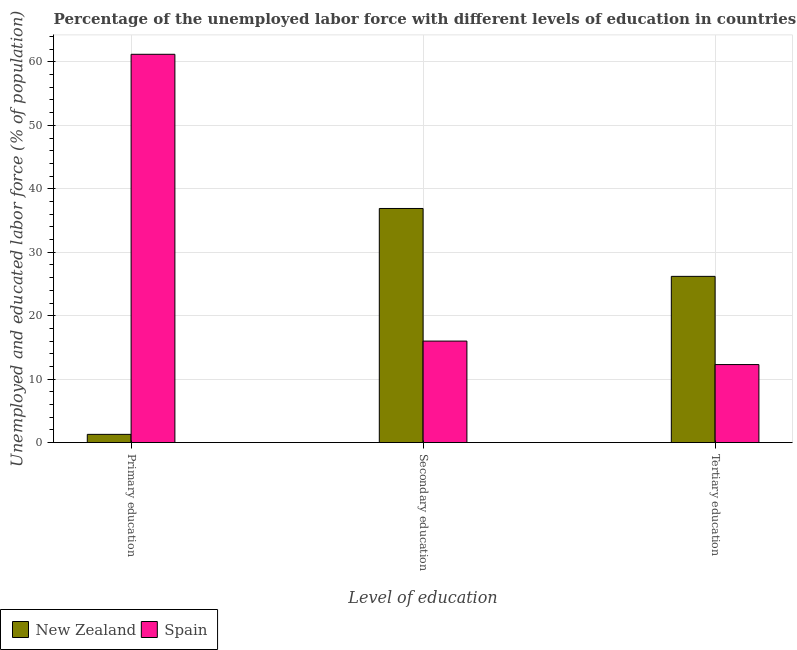How many groups of bars are there?
Your response must be concise. 3. Are the number of bars on each tick of the X-axis equal?
Offer a very short reply. Yes. How many bars are there on the 3rd tick from the left?
Your answer should be very brief. 2. How many bars are there on the 3rd tick from the right?
Offer a very short reply. 2. What is the label of the 2nd group of bars from the left?
Give a very brief answer. Secondary education. What is the percentage of labor force who received primary education in New Zealand?
Your response must be concise. 1.3. Across all countries, what is the maximum percentage of labor force who received tertiary education?
Provide a succinct answer. 26.2. Across all countries, what is the minimum percentage of labor force who received tertiary education?
Your answer should be very brief. 12.3. In which country was the percentage of labor force who received secondary education maximum?
Your response must be concise. New Zealand. In which country was the percentage of labor force who received primary education minimum?
Provide a succinct answer. New Zealand. What is the total percentage of labor force who received secondary education in the graph?
Keep it short and to the point. 52.9. What is the difference between the percentage of labor force who received tertiary education in Spain and that in New Zealand?
Your answer should be very brief. -13.9. What is the difference between the percentage of labor force who received secondary education in New Zealand and the percentage of labor force who received primary education in Spain?
Make the answer very short. -24.3. What is the average percentage of labor force who received secondary education per country?
Your response must be concise. 26.45. What is the difference between the percentage of labor force who received secondary education and percentage of labor force who received primary education in New Zealand?
Your answer should be compact. 35.6. What is the ratio of the percentage of labor force who received tertiary education in New Zealand to that in Spain?
Make the answer very short. 2.13. Is the percentage of labor force who received primary education in Spain less than that in New Zealand?
Provide a short and direct response. No. What is the difference between the highest and the second highest percentage of labor force who received tertiary education?
Your response must be concise. 13.9. What is the difference between the highest and the lowest percentage of labor force who received tertiary education?
Provide a short and direct response. 13.9. In how many countries, is the percentage of labor force who received primary education greater than the average percentage of labor force who received primary education taken over all countries?
Provide a succinct answer. 1. What does the 1st bar from the left in Tertiary education represents?
Make the answer very short. New Zealand. What does the 2nd bar from the right in Secondary education represents?
Your answer should be very brief. New Zealand. Does the graph contain any zero values?
Offer a terse response. No. Does the graph contain grids?
Your response must be concise. Yes. Where does the legend appear in the graph?
Provide a short and direct response. Bottom left. How many legend labels are there?
Offer a very short reply. 2. What is the title of the graph?
Your answer should be very brief. Percentage of the unemployed labor force with different levels of education in countries. Does "Faeroe Islands" appear as one of the legend labels in the graph?
Provide a succinct answer. No. What is the label or title of the X-axis?
Give a very brief answer. Level of education. What is the label or title of the Y-axis?
Provide a short and direct response. Unemployed and educated labor force (% of population). What is the Unemployed and educated labor force (% of population) in New Zealand in Primary education?
Offer a very short reply. 1.3. What is the Unemployed and educated labor force (% of population) in Spain in Primary education?
Your answer should be compact. 61.2. What is the Unemployed and educated labor force (% of population) in New Zealand in Secondary education?
Give a very brief answer. 36.9. What is the Unemployed and educated labor force (% of population) of Spain in Secondary education?
Offer a very short reply. 16. What is the Unemployed and educated labor force (% of population) of New Zealand in Tertiary education?
Your answer should be very brief. 26.2. What is the Unemployed and educated labor force (% of population) in Spain in Tertiary education?
Your answer should be compact. 12.3. Across all Level of education, what is the maximum Unemployed and educated labor force (% of population) of New Zealand?
Offer a terse response. 36.9. Across all Level of education, what is the maximum Unemployed and educated labor force (% of population) of Spain?
Offer a very short reply. 61.2. Across all Level of education, what is the minimum Unemployed and educated labor force (% of population) of New Zealand?
Your answer should be very brief. 1.3. Across all Level of education, what is the minimum Unemployed and educated labor force (% of population) in Spain?
Your response must be concise. 12.3. What is the total Unemployed and educated labor force (% of population) in New Zealand in the graph?
Keep it short and to the point. 64.4. What is the total Unemployed and educated labor force (% of population) in Spain in the graph?
Give a very brief answer. 89.5. What is the difference between the Unemployed and educated labor force (% of population) of New Zealand in Primary education and that in Secondary education?
Offer a terse response. -35.6. What is the difference between the Unemployed and educated labor force (% of population) of Spain in Primary education and that in Secondary education?
Provide a short and direct response. 45.2. What is the difference between the Unemployed and educated labor force (% of population) in New Zealand in Primary education and that in Tertiary education?
Provide a succinct answer. -24.9. What is the difference between the Unemployed and educated labor force (% of population) in Spain in Primary education and that in Tertiary education?
Provide a succinct answer. 48.9. What is the difference between the Unemployed and educated labor force (% of population) in New Zealand in Secondary education and that in Tertiary education?
Make the answer very short. 10.7. What is the difference between the Unemployed and educated labor force (% of population) in New Zealand in Primary education and the Unemployed and educated labor force (% of population) in Spain in Secondary education?
Keep it short and to the point. -14.7. What is the difference between the Unemployed and educated labor force (% of population) in New Zealand in Primary education and the Unemployed and educated labor force (% of population) in Spain in Tertiary education?
Keep it short and to the point. -11. What is the difference between the Unemployed and educated labor force (% of population) of New Zealand in Secondary education and the Unemployed and educated labor force (% of population) of Spain in Tertiary education?
Your answer should be compact. 24.6. What is the average Unemployed and educated labor force (% of population) of New Zealand per Level of education?
Offer a very short reply. 21.47. What is the average Unemployed and educated labor force (% of population) in Spain per Level of education?
Give a very brief answer. 29.83. What is the difference between the Unemployed and educated labor force (% of population) in New Zealand and Unemployed and educated labor force (% of population) in Spain in Primary education?
Offer a very short reply. -59.9. What is the difference between the Unemployed and educated labor force (% of population) in New Zealand and Unemployed and educated labor force (% of population) in Spain in Secondary education?
Make the answer very short. 20.9. What is the difference between the Unemployed and educated labor force (% of population) in New Zealand and Unemployed and educated labor force (% of population) in Spain in Tertiary education?
Your response must be concise. 13.9. What is the ratio of the Unemployed and educated labor force (% of population) in New Zealand in Primary education to that in Secondary education?
Make the answer very short. 0.04. What is the ratio of the Unemployed and educated labor force (% of population) in Spain in Primary education to that in Secondary education?
Give a very brief answer. 3.83. What is the ratio of the Unemployed and educated labor force (% of population) of New Zealand in Primary education to that in Tertiary education?
Offer a terse response. 0.05. What is the ratio of the Unemployed and educated labor force (% of population) of Spain in Primary education to that in Tertiary education?
Offer a terse response. 4.98. What is the ratio of the Unemployed and educated labor force (% of population) of New Zealand in Secondary education to that in Tertiary education?
Offer a terse response. 1.41. What is the ratio of the Unemployed and educated labor force (% of population) in Spain in Secondary education to that in Tertiary education?
Your answer should be very brief. 1.3. What is the difference between the highest and the second highest Unemployed and educated labor force (% of population) of New Zealand?
Provide a succinct answer. 10.7. What is the difference between the highest and the second highest Unemployed and educated labor force (% of population) of Spain?
Keep it short and to the point. 45.2. What is the difference between the highest and the lowest Unemployed and educated labor force (% of population) of New Zealand?
Keep it short and to the point. 35.6. What is the difference between the highest and the lowest Unemployed and educated labor force (% of population) of Spain?
Your answer should be very brief. 48.9. 